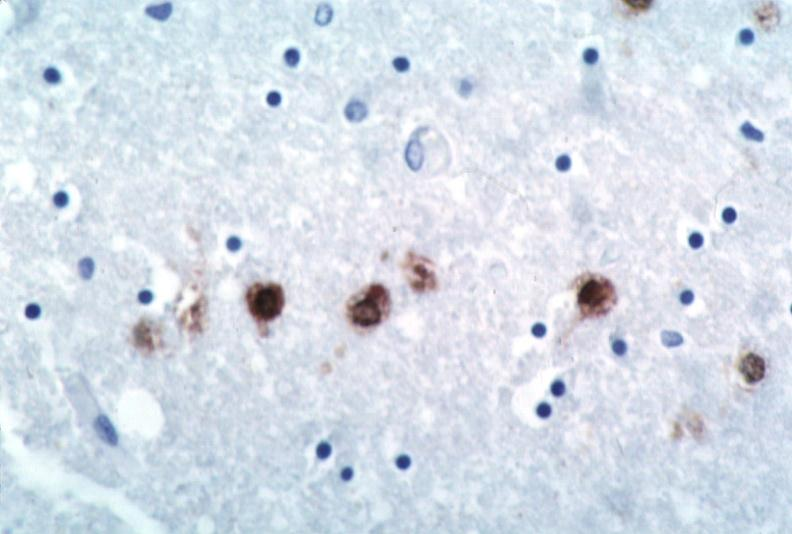s aplastic present?
Answer the question using a single word or phrase. No 